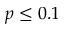Convert formula to latex. <formula><loc_0><loc_0><loc_500><loc_500>p \leq 0 . 1</formula> 